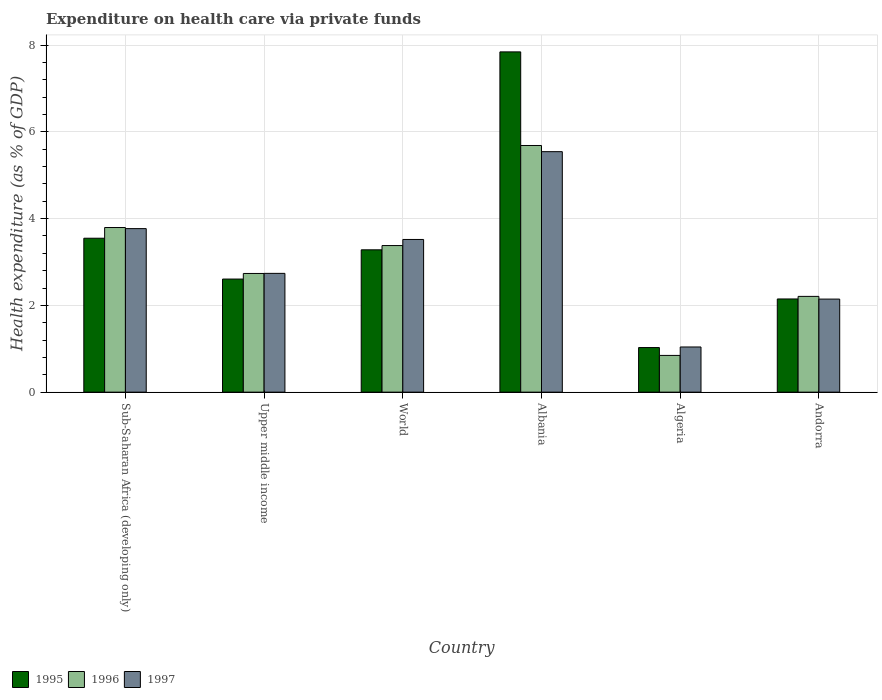Are the number of bars per tick equal to the number of legend labels?
Provide a succinct answer. Yes. How many bars are there on the 2nd tick from the right?
Make the answer very short. 3. What is the label of the 4th group of bars from the left?
Provide a succinct answer. Albania. In how many cases, is the number of bars for a given country not equal to the number of legend labels?
Keep it short and to the point. 0. What is the expenditure made on health care in 1995 in Upper middle income?
Provide a succinct answer. 2.61. Across all countries, what is the maximum expenditure made on health care in 1995?
Keep it short and to the point. 7.84. Across all countries, what is the minimum expenditure made on health care in 1995?
Ensure brevity in your answer.  1.03. In which country was the expenditure made on health care in 1995 maximum?
Provide a succinct answer. Albania. In which country was the expenditure made on health care in 1995 minimum?
Your answer should be very brief. Algeria. What is the total expenditure made on health care in 1995 in the graph?
Your answer should be very brief. 20.46. What is the difference between the expenditure made on health care in 1997 in Andorra and that in World?
Give a very brief answer. -1.37. What is the difference between the expenditure made on health care in 1996 in World and the expenditure made on health care in 1995 in Andorra?
Make the answer very short. 1.23. What is the average expenditure made on health care in 1997 per country?
Your answer should be very brief. 3.13. What is the difference between the expenditure made on health care of/in 1997 and expenditure made on health care of/in 1995 in Andorra?
Provide a succinct answer. -0. In how many countries, is the expenditure made on health care in 1995 greater than 5.2 %?
Ensure brevity in your answer.  1. What is the ratio of the expenditure made on health care in 1997 in Albania to that in Sub-Saharan Africa (developing only)?
Your answer should be compact. 1.47. Is the expenditure made on health care in 1995 in Algeria less than that in Andorra?
Offer a very short reply. Yes. What is the difference between the highest and the second highest expenditure made on health care in 1996?
Your response must be concise. -0.42. What is the difference between the highest and the lowest expenditure made on health care in 1996?
Keep it short and to the point. 4.84. Is it the case that in every country, the sum of the expenditure made on health care in 1996 and expenditure made on health care in 1997 is greater than the expenditure made on health care in 1995?
Make the answer very short. Yes. How many bars are there?
Keep it short and to the point. 18. Are all the bars in the graph horizontal?
Your response must be concise. No. What is the difference between two consecutive major ticks on the Y-axis?
Your answer should be compact. 2. How are the legend labels stacked?
Offer a very short reply. Horizontal. What is the title of the graph?
Give a very brief answer. Expenditure on health care via private funds. Does "2000" appear as one of the legend labels in the graph?
Provide a succinct answer. No. What is the label or title of the X-axis?
Offer a terse response. Country. What is the label or title of the Y-axis?
Your answer should be compact. Health expenditure (as % of GDP). What is the Health expenditure (as % of GDP) in 1995 in Sub-Saharan Africa (developing only)?
Make the answer very short. 3.55. What is the Health expenditure (as % of GDP) of 1996 in Sub-Saharan Africa (developing only)?
Offer a very short reply. 3.79. What is the Health expenditure (as % of GDP) in 1997 in Sub-Saharan Africa (developing only)?
Make the answer very short. 3.77. What is the Health expenditure (as % of GDP) in 1995 in Upper middle income?
Ensure brevity in your answer.  2.61. What is the Health expenditure (as % of GDP) in 1996 in Upper middle income?
Your response must be concise. 2.74. What is the Health expenditure (as % of GDP) of 1997 in Upper middle income?
Your answer should be very brief. 2.74. What is the Health expenditure (as % of GDP) in 1995 in World?
Provide a succinct answer. 3.28. What is the Health expenditure (as % of GDP) in 1996 in World?
Offer a terse response. 3.38. What is the Health expenditure (as % of GDP) of 1997 in World?
Offer a very short reply. 3.52. What is the Health expenditure (as % of GDP) of 1995 in Albania?
Provide a short and direct response. 7.84. What is the Health expenditure (as % of GDP) in 1996 in Albania?
Your answer should be compact. 5.69. What is the Health expenditure (as % of GDP) of 1997 in Albania?
Keep it short and to the point. 5.54. What is the Health expenditure (as % of GDP) in 1995 in Algeria?
Make the answer very short. 1.03. What is the Health expenditure (as % of GDP) of 1996 in Algeria?
Ensure brevity in your answer.  0.85. What is the Health expenditure (as % of GDP) of 1997 in Algeria?
Your answer should be very brief. 1.04. What is the Health expenditure (as % of GDP) in 1995 in Andorra?
Provide a short and direct response. 2.15. What is the Health expenditure (as % of GDP) in 1996 in Andorra?
Your answer should be compact. 2.21. What is the Health expenditure (as % of GDP) of 1997 in Andorra?
Ensure brevity in your answer.  2.15. Across all countries, what is the maximum Health expenditure (as % of GDP) in 1995?
Your response must be concise. 7.84. Across all countries, what is the maximum Health expenditure (as % of GDP) of 1996?
Your answer should be compact. 5.69. Across all countries, what is the maximum Health expenditure (as % of GDP) of 1997?
Provide a succinct answer. 5.54. Across all countries, what is the minimum Health expenditure (as % of GDP) of 1995?
Offer a terse response. 1.03. Across all countries, what is the minimum Health expenditure (as % of GDP) in 1996?
Give a very brief answer. 0.85. Across all countries, what is the minimum Health expenditure (as % of GDP) in 1997?
Make the answer very short. 1.04. What is the total Health expenditure (as % of GDP) of 1995 in the graph?
Provide a succinct answer. 20.46. What is the total Health expenditure (as % of GDP) of 1996 in the graph?
Your response must be concise. 18.65. What is the total Health expenditure (as % of GDP) of 1997 in the graph?
Ensure brevity in your answer.  18.76. What is the difference between the Health expenditure (as % of GDP) in 1996 in Sub-Saharan Africa (developing only) and that in Upper middle income?
Provide a short and direct response. 1.06. What is the difference between the Health expenditure (as % of GDP) of 1997 in Sub-Saharan Africa (developing only) and that in Upper middle income?
Offer a very short reply. 1.03. What is the difference between the Health expenditure (as % of GDP) of 1995 in Sub-Saharan Africa (developing only) and that in World?
Offer a very short reply. 0.27. What is the difference between the Health expenditure (as % of GDP) of 1996 in Sub-Saharan Africa (developing only) and that in World?
Offer a terse response. 0.42. What is the difference between the Health expenditure (as % of GDP) in 1997 in Sub-Saharan Africa (developing only) and that in World?
Keep it short and to the point. 0.25. What is the difference between the Health expenditure (as % of GDP) of 1995 in Sub-Saharan Africa (developing only) and that in Albania?
Your answer should be compact. -4.3. What is the difference between the Health expenditure (as % of GDP) in 1996 in Sub-Saharan Africa (developing only) and that in Albania?
Give a very brief answer. -1.89. What is the difference between the Health expenditure (as % of GDP) of 1997 in Sub-Saharan Africa (developing only) and that in Albania?
Offer a very short reply. -1.77. What is the difference between the Health expenditure (as % of GDP) of 1995 in Sub-Saharan Africa (developing only) and that in Algeria?
Your answer should be compact. 2.52. What is the difference between the Health expenditure (as % of GDP) of 1996 in Sub-Saharan Africa (developing only) and that in Algeria?
Offer a very short reply. 2.95. What is the difference between the Health expenditure (as % of GDP) in 1997 in Sub-Saharan Africa (developing only) and that in Algeria?
Offer a terse response. 2.73. What is the difference between the Health expenditure (as % of GDP) in 1995 in Sub-Saharan Africa (developing only) and that in Andorra?
Provide a succinct answer. 1.4. What is the difference between the Health expenditure (as % of GDP) of 1996 in Sub-Saharan Africa (developing only) and that in Andorra?
Make the answer very short. 1.59. What is the difference between the Health expenditure (as % of GDP) in 1997 in Sub-Saharan Africa (developing only) and that in Andorra?
Your answer should be very brief. 1.62. What is the difference between the Health expenditure (as % of GDP) in 1995 in Upper middle income and that in World?
Your response must be concise. -0.67. What is the difference between the Health expenditure (as % of GDP) of 1996 in Upper middle income and that in World?
Ensure brevity in your answer.  -0.64. What is the difference between the Health expenditure (as % of GDP) in 1997 in Upper middle income and that in World?
Ensure brevity in your answer.  -0.78. What is the difference between the Health expenditure (as % of GDP) of 1995 in Upper middle income and that in Albania?
Your answer should be compact. -5.24. What is the difference between the Health expenditure (as % of GDP) of 1996 in Upper middle income and that in Albania?
Your response must be concise. -2.95. What is the difference between the Health expenditure (as % of GDP) in 1997 in Upper middle income and that in Albania?
Make the answer very short. -2.81. What is the difference between the Health expenditure (as % of GDP) in 1995 in Upper middle income and that in Algeria?
Offer a very short reply. 1.58. What is the difference between the Health expenditure (as % of GDP) in 1996 in Upper middle income and that in Algeria?
Provide a succinct answer. 1.89. What is the difference between the Health expenditure (as % of GDP) in 1997 in Upper middle income and that in Algeria?
Make the answer very short. 1.7. What is the difference between the Health expenditure (as % of GDP) in 1995 in Upper middle income and that in Andorra?
Your answer should be compact. 0.46. What is the difference between the Health expenditure (as % of GDP) in 1996 in Upper middle income and that in Andorra?
Your answer should be very brief. 0.53. What is the difference between the Health expenditure (as % of GDP) in 1997 in Upper middle income and that in Andorra?
Your response must be concise. 0.59. What is the difference between the Health expenditure (as % of GDP) in 1995 in World and that in Albania?
Offer a very short reply. -4.56. What is the difference between the Health expenditure (as % of GDP) of 1996 in World and that in Albania?
Offer a very short reply. -2.31. What is the difference between the Health expenditure (as % of GDP) of 1997 in World and that in Albania?
Give a very brief answer. -2.02. What is the difference between the Health expenditure (as % of GDP) in 1995 in World and that in Algeria?
Make the answer very short. 2.25. What is the difference between the Health expenditure (as % of GDP) of 1996 in World and that in Algeria?
Your answer should be very brief. 2.53. What is the difference between the Health expenditure (as % of GDP) of 1997 in World and that in Algeria?
Offer a terse response. 2.48. What is the difference between the Health expenditure (as % of GDP) of 1995 in World and that in Andorra?
Give a very brief answer. 1.13. What is the difference between the Health expenditure (as % of GDP) of 1996 in World and that in Andorra?
Your response must be concise. 1.17. What is the difference between the Health expenditure (as % of GDP) of 1997 in World and that in Andorra?
Provide a short and direct response. 1.37. What is the difference between the Health expenditure (as % of GDP) in 1995 in Albania and that in Algeria?
Offer a very short reply. 6.82. What is the difference between the Health expenditure (as % of GDP) of 1996 in Albania and that in Algeria?
Your answer should be very brief. 4.84. What is the difference between the Health expenditure (as % of GDP) in 1997 in Albania and that in Algeria?
Give a very brief answer. 4.5. What is the difference between the Health expenditure (as % of GDP) of 1995 in Albania and that in Andorra?
Provide a succinct answer. 5.7. What is the difference between the Health expenditure (as % of GDP) in 1996 in Albania and that in Andorra?
Your answer should be very brief. 3.48. What is the difference between the Health expenditure (as % of GDP) of 1997 in Albania and that in Andorra?
Offer a very short reply. 3.4. What is the difference between the Health expenditure (as % of GDP) in 1995 in Algeria and that in Andorra?
Ensure brevity in your answer.  -1.12. What is the difference between the Health expenditure (as % of GDP) of 1996 in Algeria and that in Andorra?
Ensure brevity in your answer.  -1.36. What is the difference between the Health expenditure (as % of GDP) in 1997 in Algeria and that in Andorra?
Provide a short and direct response. -1.1. What is the difference between the Health expenditure (as % of GDP) in 1995 in Sub-Saharan Africa (developing only) and the Health expenditure (as % of GDP) in 1996 in Upper middle income?
Your response must be concise. 0.81. What is the difference between the Health expenditure (as % of GDP) in 1995 in Sub-Saharan Africa (developing only) and the Health expenditure (as % of GDP) in 1997 in Upper middle income?
Make the answer very short. 0.81. What is the difference between the Health expenditure (as % of GDP) of 1996 in Sub-Saharan Africa (developing only) and the Health expenditure (as % of GDP) of 1997 in Upper middle income?
Make the answer very short. 1.06. What is the difference between the Health expenditure (as % of GDP) in 1995 in Sub-Saharan Africa (developing only) and the Health expenditure (as % of GDP) in 1996 in World?
Your answer should be very brief. 0.17. What is the difference between the Health expenditure (as % of GDP) in 1995 in Sub-Saharan Africa (developing only) and the Health expenditure (as % of GDP) in 1997 in World?
Your answer should be compact. 0.03. What is the difference between the Health expenditure (as % of GDP) of 1996 in Sub-Saharan Africa (developing only) and the Health expenditure (as % of GDP) of 1997 in World?
Offer a terse response. 0.28. What is the difference between the Health expenditure (as % of GDP) in 1995 in Sub-Saharan Africa (developing only) and the Health expenditure (as % of GDP) in 1996 in Albania?
Provide a short and direct response. -2.14. What is the difference between the Health expenditure (as % of GDP) of 1995 in Sub-Saharan Africa (developing only) and the Health expenditure (as % of GDP) of 1997 in Albania?
Your response must be concise. -2. What is the difference between the Health expenditure (as % of GDP) of 1996 in Sub-Saharan Africa (developing only) and the Health expenditure (as % of GDP) of 1997 in Albania?
Keep it short and to the point. -1.75. What is the difference between the Health expenditure (as % of GDP) of 1995 in Sub-Saharan Africa (developing only) and the Health expenditure (as % of GDP) of 1996 in Algeria?
Your response must be concise. 2.7. What is the difference between the Health expenditure (as % of GDP) in 1995 in Sub-Saharan Africa (developing only) and the Health expenditure (as % of GDP) in 1997 in Algeria?
Offer a terse response. 2.51. What is the difference between the Health expenditure (as % of GDP) of 1996 in Sub-Saharan Africa (developing only) and the Health expenditure (as % of GDP) of 1997 in Algeria?
Make the answer very short. 2.75. What is the difference between the Health expenditure (as % of GDP) in 1995 in Sub-Saharan Africa (developing only) and the Health expenditure (as % of GDP) in 1996 in Andorra?
Your response must be concise. 1.34. What is the difference between the Health expenditure (as % of GDP) of 1995 in Sub-Saharan Africa (developing only) and the Health expenditure (as % of GDP) of 1997 in Andorra?
Offer a very short reply. 1.4. What is the difference between the Health expenditure (as % of GDP) of 1996 in Sub-Saharan Africa (developing only) and the Health expenditure (as % of GDP) of 1997 in Andorra?
Give a very brief answer. 1.65. What is the difference between the Health expenditure (as % of GDP) of 1995 in Upper middle income and the Health expenditure (as % of GDP) of 1996 in World?
Ensure brevity in your answer.  -0.77. What is the difference between the Health expenditure (as % of GDP) of 1995 in Upper middle income and the Health expenditure (as % of GDP) of 1997 in World?
Your response must be concise. -0.91. What is the difference between the Health expenditure (as % of GDP) in 1996 in Upper middle income and the Health expenditure (as % of GDP) in 1997 in World?
Your response must be concise. -0.78. What is the difference between the Health expenditure (as % of GDP) of 1995 in Upper middle income and the Health expenditure (as % of GDP) of 1996 in Albania?
Offer a terse response. -3.08. What is the difference between the Health expenditure (as % of GDP) of 1995 in Upper middle income and the Health expenditure (as % of GDP) of 1997 in Albania?
Provide a short and direct response. -2.94. What is the difference between the Health expenditure (as % of GDP) in 1996 in Upper middle income and the Health expenditure (as % of GDP) in 1997 in Albania?
Offer a very short reply. -2.81. What is the difference between the Health expenditure (as % of GDP) of 1995 in Upper middle income and the Health expenditure (as % of GDP) of 1996 in Algeria?
Make the answer very short. 1.76. What is the difference between the Health expenditure (as % of GDP) of 1995 in Upper middle income and the Health expenditure (as % of GDP) of 1997 in Algeria?
Offer a terse response. 1.57. What is the difference between the Health expenditure (as % of GDP) of 1996 in Upper middle income and the Health expenditure (as % of GDP) of 1997 in Algeria?
Your answer should be very brief. 1.69. What is the difference between the Health expenditure (as % of GDP) in 1995 in Upper middle income and the Health expenditure (as % of GDP) in 1996 in Andorra?
Offer a terse response. 0.4. What is the difference between the Health expenditure (as % of GDP) of 1995 in Upper middle income and the Health expenditure (as % of GDP) of 1997 in Andorra?
Your response must be concise. 0.46. What is the difference between the Health expenditure (as % of GDP) in 1996 in Upper middle income and the Health expenditure (as % of GDP) in 1997 in Andorra?
Your answer should be compact. 0.59. What is the difference between the Health expenditure (as % of GDP) in 1995 in World and the Health expenditure (as % of GDP) in 1996 in Albania?
Your response must be concise. -2.4. What is the difference between the Health expenditure (as % of GDP) of 1995 in World and the Health expenditure (as % of GDP) of 1997 in Albania?
Provide a short and direct response. -2.26. What is the difference between the Health expenditure (as % of GDP) in 1996 in World and the Health expenditure (as % of GDP) in 1997 in Albania?
Offer a very short reply. -2.16. What is the difference between the Health expenditure (as % of GDP) of 1995 in World and the Health expenditure (as % of GDP) of 1996 in Algeria?
Your response must be concise. 2.43. What is the difference between the Health expenditure (as % of GDP) of 1995 in World and the Health expenditure (as % of GDP) of 1997 in Algeria?
Your answer should be compact. 2.24. What is the difference between the Health expenditure (as % of GDP) of 1996 in World and the Health expenditure (as % of GDP) of 1997 in Algeria?
Give a very brief answer. 2.34. What is the difference between the Health expenditure (as % of GDP) in 1995 in World and the Health expenditure (as % of GDP) in 1996 in Andorra?
Provide a short and direct response. 1.07. What is the difference between the Health expenditure (as % of GDP) in 1995 in World and the Health expenditure (as % of GDP) in 1997 in Andorra?
Provide a succinct answer. 1.14. What is the difference between the Health expenditure (as % of GDP) in 1996 in World and the Health expenditure (as % of GDP) in 1997 in Andorra?
Provide a succinct answer. 1.23. What is the difference between the Health expenditure (as % of GDP) of 1995 in Albania and the Health expenditure (as % of GDP) of 1996 in Algeria?
Give a very brief answer. 7. What is the difference between the Health expenditure (as % of GDP) in 1995 in Albania and the Health expenditure (as % of GDP) in 1997 in Algeria?
Make the answer very short. 6.8. What is the difference between the Health expenditure (as % of GDP) of 1996 in Albania and the Health expenditure (as % of GDP) of 1997 in Algeria?
Offer a very short reply. 4.64. What is the difference between the Health expenditure (as % of GDP) in 1995 in Albania and the Health expenditure (as % of GDP) in 1996 in Andorra?
Your response must be concise. 5.64. What is the difference between the Health expenditure (as % of GDP) of 1995 in Albania and the Health expenditure (as % of GDP) of 1997 in Andorra?
Your response must be concise. 5.7. What is the difference between the Health expenditure (as % of GDP) of 1996 in Albania and the Health expenditure (as % of GDP) of 1997 in Andorra?
Give a very brief answer. 3.54. What is the difference between the Health expenditure (as % of GDP) in 1995 in Algeria and the Health expenditure (as % of GDP) in 1996 in Andorra?
Offer a terse response. -1.18. What is the difference between the Health expenditure (as % of GDP) of 1995 in Algeria and the Health expenditure (as % of GDP) of 1997 in Andorra?
Keep it short and to the point. -1.12. What is the difference between the Health expenditure (as % of GDP) of 1996 in Algeria and the Health expenditure (as % of GDP) of 1997 in Andorra?
Your answer should be very brief. -1.3. What is the average Health expenditure (as % of GDP) in 1995 per country?
Your response must be concise. 3.41. What is the average Health expenditure (as % of GDP) of 1996 per country?
Give a very brief answer. 3.11. What is the average Health expenditure (as % of GDP) in 1997 per country?
Offer a terse response. 3.13. What is the difference between the Health expenditure (as % of GDP) of 1995 and Health expenditure (as % of GDP) of 1996 in Sub-Saharan Africa (developing only)?
Ensure brevity in your answer.  -0.25. What is the difference between the Health expenditure (as % of GDP) of 1995 and Health expenditure (as % of GDP) of 1997 in Sub-Saharan Africa (developing only)?
Provide a short and direct response. -0.22. What is the difference between the Health expenditure (as % of GDP) of 1996 and Health expenditure (as % of GDP) of 1997 in Sub-Saharan Africa (developing only)?
Keep it short and to the point. 0.03. What is the difference between the Health expenditure (as % of GDP) of 1995 and Health expenditure (as % of GDP) of 1996 in Upper middle income?
Ensure brevity in your answer.  -0.13. What is the difference between the Health expenditure (as % of GDP) in 1995 and Health expenditure (as % of GDP) in 1997 in Upper middle income?
Offer a terse response. -0.13. What is the difference between the Health expenditure (as % of GDP) of 1996 and Health expenditure (as % of GDP) of 1997 in Upper middle income?
Provide a succinct answer. -0. What is the difference between the Health expenditure (as % of GDP) of 1995 and Health expenditure (as % of GDP) of 1996 in World?
Your answer should be compact. -0.1. What is the difference between the Health expenditure (as % of GDP) in 1995 and Health expenditure (as % of GDP) in 1997 in World?
Keep it short and to the point. -0.24. What is the difference between the Health expenditure (as % of GDP) in 1996 and Health expenditure (as % of GDP) in 1997 in World?
Your response must be concise. -0.14. What is the difference between the Health expenditure (as % of GDP) in 1995 and Health expenditure (as % of GDP) in 1996 in Albania?
Give a very brief answer. 2.16. What is the difference between the Health expenditure (as % of GDP) of 1995 and Health expenditure (as % of GDP) of 1997 in Albania?
Ensure brevity in your answer.  2.3. What is the difference between the Health expenditure (as % of GDP) in 1996 and Health expenditure (as % of GDP) in 1997 in Albania?
Your answer should be very brief. 0.14. What is the difference between the Health expenditure (as % of GDP) in 1995 and Health expenditure (as % of GDP) in 1996 in Algeria?
Ensure brevity in your answer.  0.18. What is the difference between the Health expenditure (as % of GDP) of 1995 and Health expenditure (as % of GDP) of 1997 in Algeria?
Provide a succinct answer. -0.01. What is the difference between the Health expenditure (as % of GDP) in 1996 and Health expenditure (as % of GDP) in 1997 in Algeria?
Offer a terse response. -0.19. What is the difference between the Health expenditure (as % of GDP) of 1995 and Health expenditure (as % of GDP) of 1996 in Andorra?
Your answer should be compact. -0.06. What is the difference between the Health expenditure (as % of GDP) in 1995 and Health expenditure (as % of GDP) in 1997 in Andorra?
Your response must be concise. 0. What is the difference between the Health expenditure (as % of GDP) in 1996 and Health expenditure (as % of GDP) in 1997 in Andorra?
Provide a short and direct response. 0.06. What is the ratio of the Health expenditure (as % of GDP) in 1995 in Sub-Saharan Africa (developing only) to that in Upper middle income?
Make the answer very short. 1.36. What is the ratio of the Health expenditure (as % of GDP) of 1996 in Sub-Saharan Africa (developing only) to that in Upper middle income?
Offer a terse response. 1.39. What is the ratio of the Health expenditure (as % of GDP) of 1997 in Sub-Saharan Africa (developing only) to that in Upper middle income?
Ensure brevity in your answer.  1.38. What is the ratio of the Health expenditure (as % of GDP) in 1995 in Sub-Saharan Africa (developing only) to that in World?
Ensure brevity in your answer.  1.08. What is the ratio of the Health expenditure (as % of GDP) of 1996 in Sub-Saharan Africa (developing only) to that in World?
Provide a short and direct response. 1.12. What is the ratio of the Health expenditure (as % of GDP) in 1997 in Sub-Saharan Africa (developing only) to that in World?
Ensure brevity in your answer.  1.07. What is the ratio of the Health expenditure (as % of GDP) in 1995 in Sub-Saharan Africa (developing only) to that in Albania?
Your response must be concise. 0.45. What is the ratio of the Health expenditure (as % of GDP) of 1996 in Sub-Saharan Africa (developing only) to that in Albania?
Your response must be concise. 0.67. What is the ratio of the Health expenditure (as % of GDP) of 1997 in Sub-Saharan Africa (developing only) to that in Albania?
Give a very brief answer. 0.68. What is the ratio of the Health expenditure (as % of GDP) of 1995 in Sub-Saharan Africa (developing only) to that in Algeria?
Offer a very short reply. 3.45. What is the ratio of the Health expenditure (as % of GDP) in 1996 in Sub-Saharan Africa (developing only) to that in Algeria?
Give a very brief answer. 4.48. What is the ratio of the Health expenditure (as % of GDP) in 1997 in Sub-Saharan Africa (developing only) to that in Algeria?
Offer a very short reply. 3.62. What is the ratio of the Health expenditure (as % of GDP) of 1995 in Sub-Saharan Africa (developing only) to that in Andorra?
Offer a terse response. 1.65. What is the ratio of the Health expenditure (as % of GDP) of 1996 in Sub-Saharan Africa (developing only) to that in Andorra?
Provide a short and direct response. 1.72. What is the ratio of the Health expenditure (as % of GDP) in 1997 in Sub-Saharan Africa (developing only) to that in Andorra?
Your response must be concise. 1.76. What is the ratio of the Health expenditure (as % of GDP) in 1995 in Upper middle income to that in World?
Keep it short and to the point. 0.79. What is the ratio of the Health expenditure (as % of GDP) in 1996 in Upper middle income to that in World?
Provide a short and direct response. 0.81. What is the ratio of the Health expenditure (as % of GDP) in 1997 in Upper middle income to that in World?
Your response must be concise. 0.78. What is the ratio of the Health expenditure (as % of GDP) in 1995 in Upper middle income to that in Albania?
Make the answer very short. 0.33. What is the ratio of the Health expenditure (as % of GDP) of 1996 in Upper middle income to that in Albania?
Your answer should be compact. 0.48. What is the ratio of the Health expenditure (as % of GDP) of 1997 in Upper middle income to that in Albania?
Provide a short and direct response. 0.49. What is the ratio of the Health expenditure (as % of GDP) in 1995 in Upper middle income to that in Algeria?
Offer a very short reply. 2.54. What is the ratio of the Health expenditure (as % of GDP) in 1996 in Upper middle income to that in Algeria?
Offer a very short reply. 3.23. What is the ratio of the Health expenditure (as % of GDP) in 1997 in Upper middle income to that in Algeria?
Provide a succinct answer. 2.63. What is the ratio of the Health expenditure (as % of GDP) in 1995 in Upper middle income to that in Andorra?
Offer a terse response. 1.21. What is the ratio of the Health expenditure (as % of GDP) of 1996 in Upper middle income to that in Andorra?
Offer a terse response. 1.24. What is the ratio of the Health expenditure (as % of GDP) of 1997 in Upper middle income to that in Andorra?
Your answer should be compact. 1.28. What is the ratio of the Health expenditure (as % of GDP) in 1995 in World to that in Albania?
Your response must be concise. 0.42. What is the ratio of the Health expenditure (as % of GDP) of 1996 in World to that in Albania?
Provide a short and direct response. 0.59. What is the ratio of the Health expenditure (as % of GDP) of 1997 in World to that in Albania?
Your response must be concise. 0.63. What is the ratio of the Health expenditure (as % of GDP) in 1995 in World to that in Algeria?
Make the answer very short. 3.19. What is the ratio of the Health expenditure (as % of GDP) in 1996 in World to that in Algeria?
Your response must be concise. 3.99. What is the ratio of the Health expenditure (as % of GDP) in 1997 in World to that in Algeria?
Ensure brevity in your answer.  3.38. What is the ratio of the Health expenditure (as % of GDP) in 1995 in World to that in Andorra?
Your answer should be compact. 1.53. What is the ratio of the Health expenditure (as % of GDP) in 1996 in World to that in Andorra?
Make the answer very short. 1.53. What is the ratio of the Health expenditure (as % of GDP) in 1997 in World to that in Andorra?
Your answer should be very brief. 1.64. What is the ratio of the Health expenditure (as % of GDP) in 1995 in Albania to that in Algeria?
Your answer should be compact. 7.63. What is the ratio of the Health expenditure (as % of GDP) in 1996 in Albania to that in Algeria?
Provide a succinct answer. 6.71. What is the ratio of the Health expenditure (as % of GDP) of 1997 in Albania to that in Algeria?
Your answer should be compact. 5.32. What is the ratio of the Health expenditure (as % of GDP) in 1995 in Albania to that in Andorra?
Offer a very short reply. 3.65. What is the ratio of the Health expenditure (as % of GDP) in 1996 in Albania to that in Andorra?
Provide a short and direct response. 2.58. What is the ratio of the Health expenditure (as % of GDP) in 1997 in Albania to that in Andorra?
Provide a succinct answer. 2.58. What is the ratio of the Health expenditure (as % of GDP) of 1995 in Algeria to that in Andorra?
Provide a short and direct response. 0.48. What is the ratio of the Health expenditure (as % of GDP) in 1996 in Algeria to that in Andorra?
Your answer should be very brief. 0.38. What is the ratio of the Health expenditure (as % of GDP) of 1997 in Algeria to that in Andorra?
Offer a very short reply. 0.49. What is the difference between the highest and the second highest Health expenditure (as % of GDP) in 1995?
Your answer should be compact. 4.3. What is the difference between the highest and the second highest Health expenditure (as % of GDP) of 1996?
Your answer should be compact. 1.89. What is the difference between the highest and the second highest Health expenditure (as % of GDP) of 1997?
Offer a terse response. 1.77. What is the difference between the highest and the lowest Health expenditure (as % of GDP) of 1995?
Give a very brief answer. 6.82. What is the difference between the highest and the lowest Health expenditure (as % of GDP) of 1996?
Ensure brevity in your answer.  4.84. What is the difference between the highest and the lowest Health expenditure (as % of GDP) of 1997?
Offer a very short reply. 4.5. 